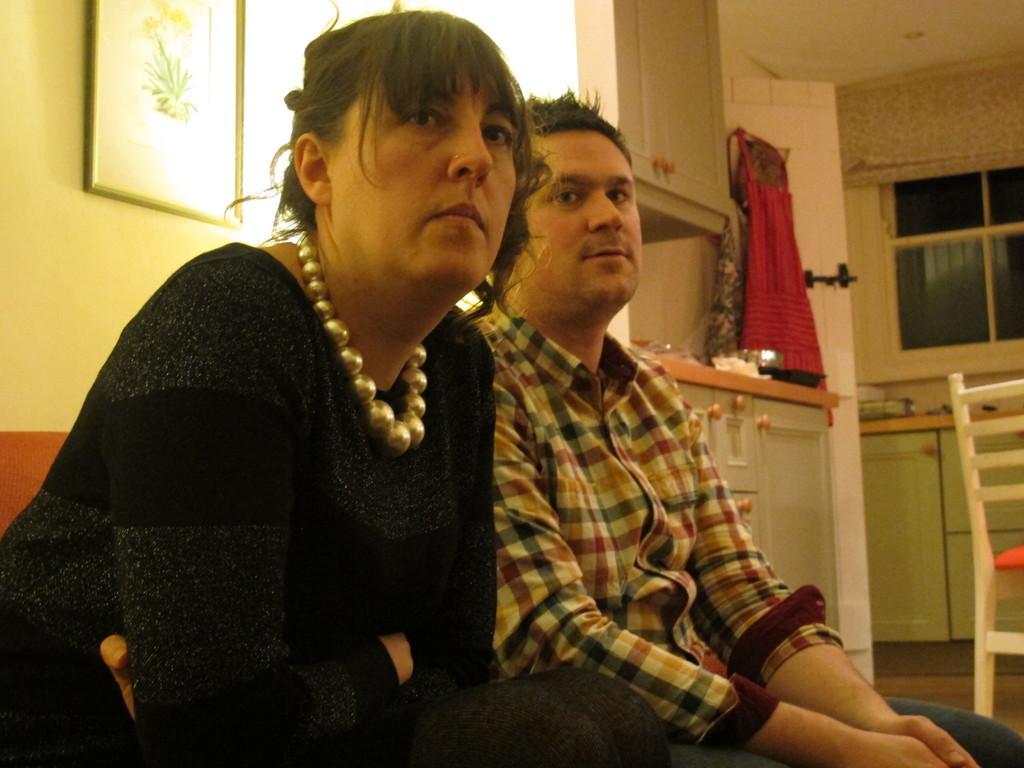Can you describe this image briefly? In this image, I can see two persons sitting. At the top left side of the image, there is a photo frame attached to the wall. On the right side of the image, I can see the cupboards, clothes, window and a chair. 